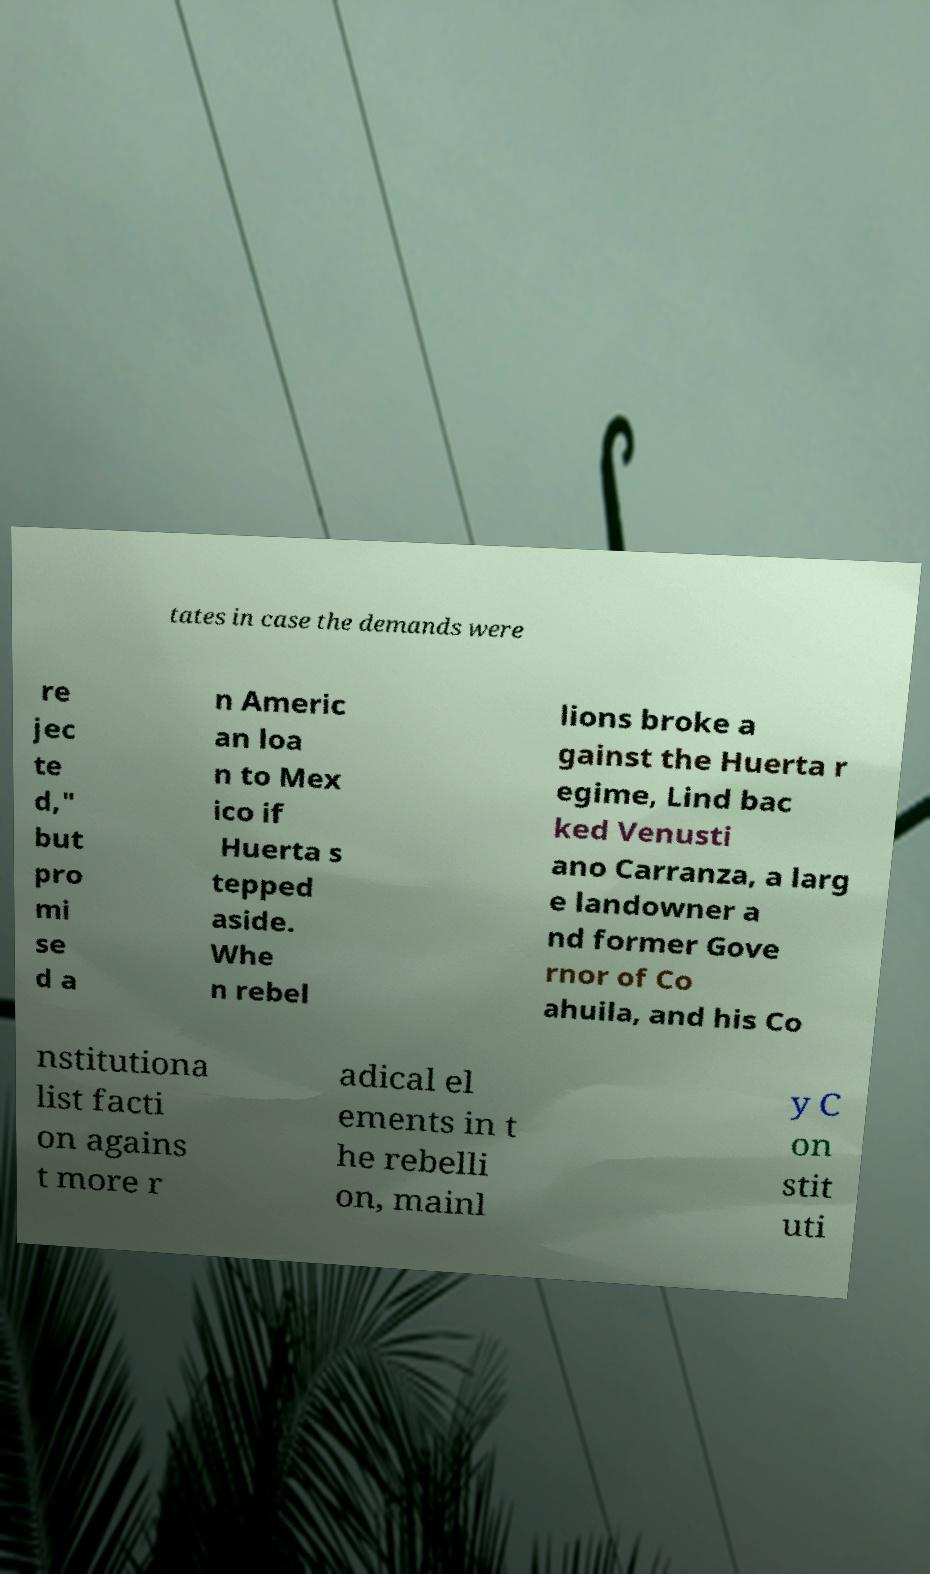Could you extract and type out the text from this image? tates in case the demands were re jec te d," but pro mi se d a n Americ an loa n to Mex ico if Huerta s tepped aside. Whe n rebel lions broke a gainst the Huerta r egime, Lind bac ked Venusti ano Carranza, a larg e landowner a nd former Gove rnor of Co ahuila, and his Co nstitutiona list facti on agains t more r adical el ements in t he rebelli on, mainl y C on stit uti 